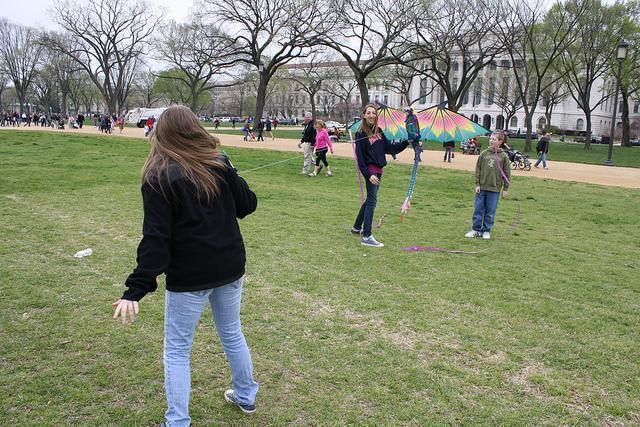What would you likely put in the thing on the ground that looks like garbage?
Choose the correct response and explain in the format: 'Answer: answer
Rationale: rationale.'
Options: Hamburger, dollar bills, toys, water. Answer: water.
Rationale: The water is in the garbage. 